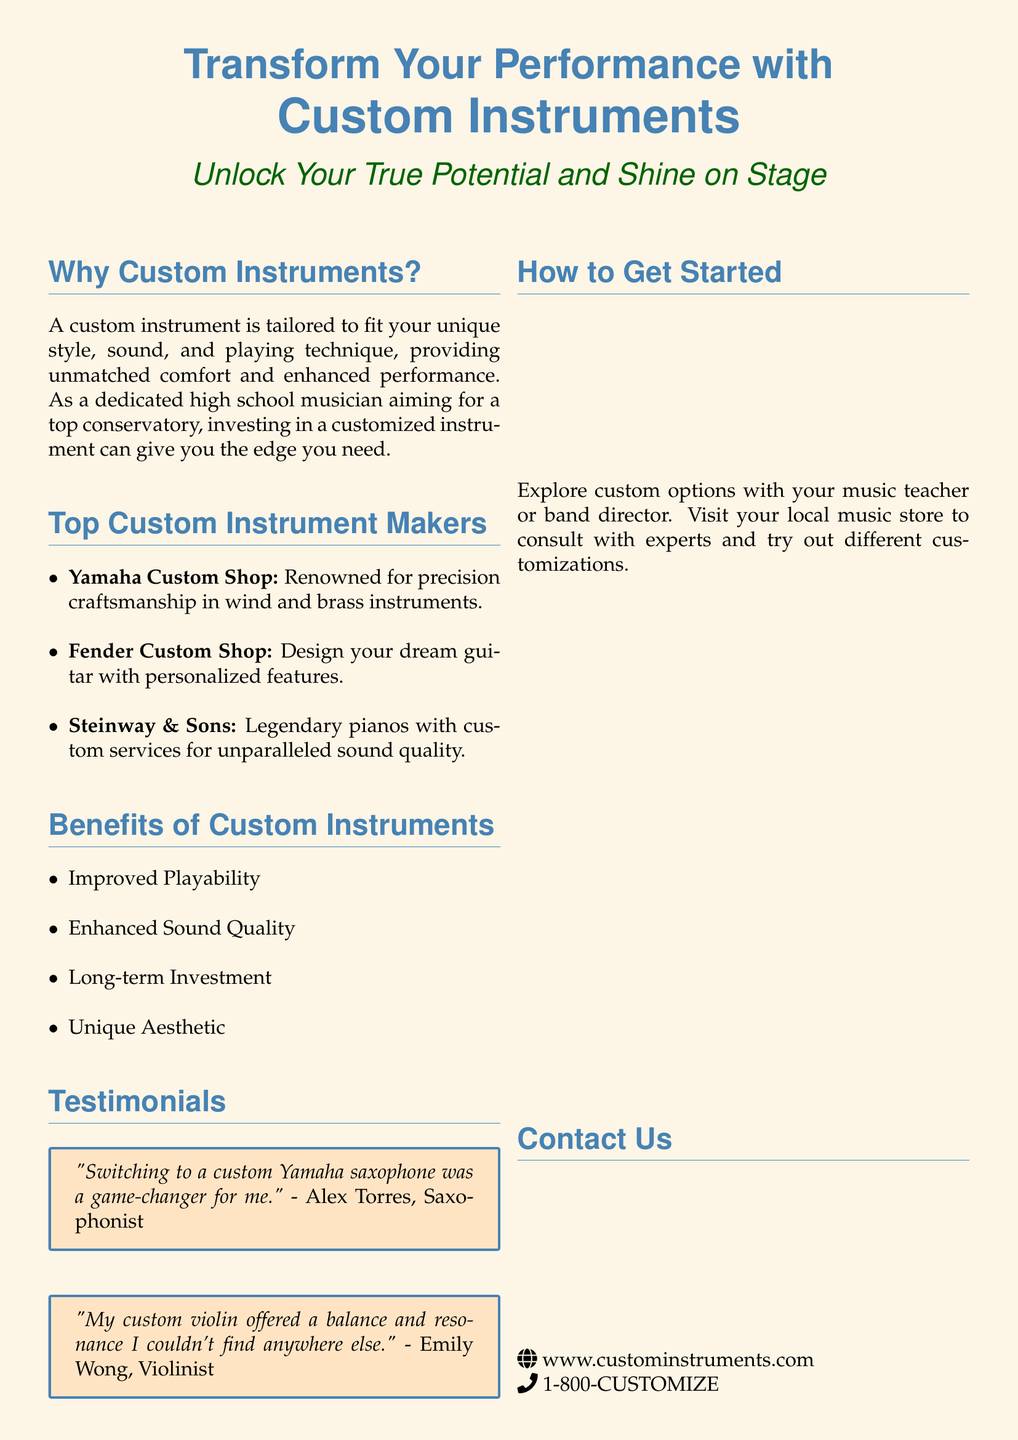What is the title of the advertisement? The title of the advertisement is presented prominently at the beginning of the document and reads "Transform Your Performance with Custom Instruments."
Answer: Transform Your Performance with Custom Instruments What does the advertisement suggest about custom instruments? The advertisement states that custom instruments are tailored to fit unique styles, offering unmatched comfort and enhanced performance.
Answer: Tailored to fit your unique style Which company is known for precision craftsmanship in wind and brass instruments? The document lists "Yamaha Custom Shop" as the company renowned for precision craftsmanship in wind and brass instruments.
Answer: Yamaha Custom Shop What is one benefit of custom instruments mentioned in the document? Multiple benefits are mentioned, including "Improved Playability," which is listed in the benefits section.
Answer: Improved Playability Who provided a testimonial about a custom Yamaha saxophone? The testimonial section features a quote from Alex Torres regarding his satisfaction with a custom Yamaha saxophone.
Answer: Alex Torres How can a young musician get started with custom instruments? The document recommends that young musicians consult with their music teacher or band director to explore custom options.
Answer: Consult with your music teacher or band director What is the phone number provided in the advertisement? The advertisement provides a contact number for inquiries, which is stated as "1-800-CUSTOMIZE."
Answer: 1-800-CUSTOMIZE Which type of instrument did Emily Wong provide a testimonial for? Emily Wong shared her experience regarding a custom instrument, specifically stating it was a custom violin.
Answer: Custom violin What type of design does the Fender Custom Shop offer? The Fender Custom Shop specializes in designing personalized guitars with customized features.
Answer: Personalized guitars 